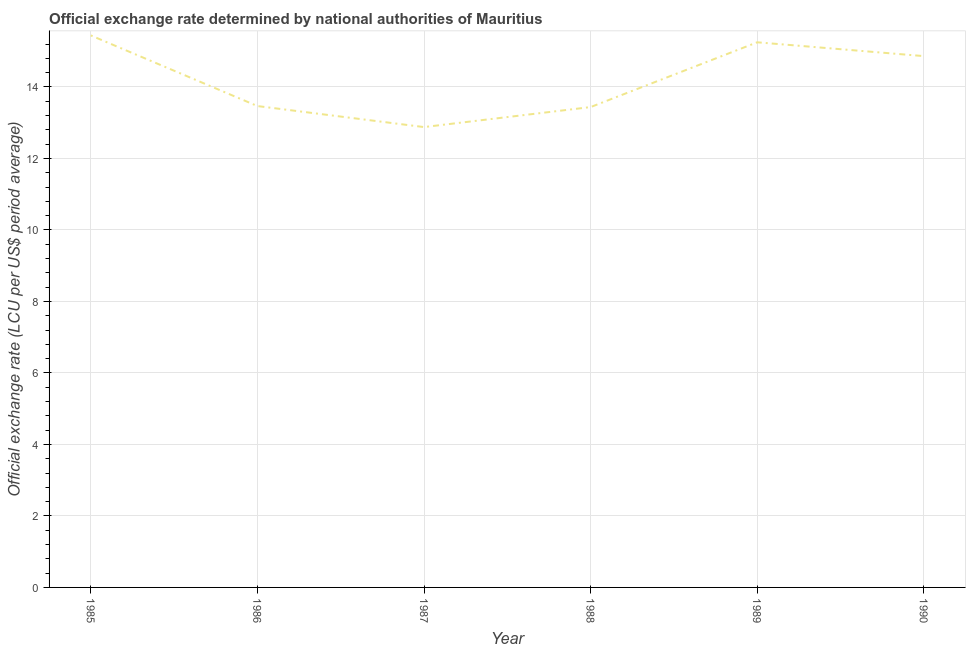What is the official exchange rate in 1985?
Make the answer very short. 15.44. Across all years, what is the maximum official exchange rate?
Provide a short and direct response. 15.44. Across all years, what is the minimum official exchange rate?
Your answer should be very brief. 12.88. What is the sum of the official exchange rate?
Give a very brief answer. 85.34. What is the difference between the official exchange rate in 1985 and 1987?
Your response must be concise. 2.56. What is the average official exchange rate per year?
Your answer should be very brief. 14.22. What is the median official exchange rate?
Keep it short and to the point. 14.16. Do a majority of the years between 1985 and 1988 (inclusive) have official exchange rate greater than 6.4 ?
Give a very brief answer. Yes. What is the ratio of the official exchange rate in 1987 to that in 1988?
Provide a succinct answer. 0.96. Is the difference between the official exchange rate in 1988 and 1989 greater than the difference between any two years?
Your answer should be compact. No. What is the difference between the highest and the second highest official exchange rate?
Make the answer very short. 0.19. What is the difference between the highest and the lowest official exchange rate?
Keep it short and to the point. 2.56. In how many years, is the official exchange rate greater than the average official exchange rate taken over all years?
Your response must be concise. 3. Does the official exchange rate monotonically increase over the years?
Your answer should be very brief. No. How many lines are there?
Make the answer very short. 1. What is the difference between two consecutive major ticks on the Y-axis?
Give a very brief answer. 2. Are the values on the major ticks of Y-axis written in scientific E-notation?
Offer a terse response. No. What is the title of the graph?
Your response must be concise. Official exchange rate determined by national authorities of Mauritius. What is the label or title of the X-axis?
Provide a short and direct response. Year. What is the label or title of the Y-axis?
Offer a terse response. Official exchange rate (LCU per US$ period average). What is the Official exchange rate (LCU per US$ period average) of 1985?
Provide a short and direct response. 15.44. What is the Official exchange rate (LCU per US$ period average) of 1986?
Offer a very short reply. 13.47. What is the Official exchange rate (LCU per US$ period average) of 1987?
Provide a short and direct response. 12.88. What is the Official exchange rate (LCU per US$ period average) in 1988?
Keep it short and to the point. 13.44. What is the Official exchange rate (LCU per US$ period average) in 1989?
Your response must be concise. 15.25. What is the Official exchange rate (LCU per US$ period average) of 1990?
Provide a succinct answer. 14.86. What is the difference between the Official exchange rate (LCU per US$ period average) in 1985 and 1986?
Your answer should be very brief. 1.98. What is the difference between the Official exchange rate (LCU per US$ period average) in 1985 and 1987?
Your answer should be compact. 2.56. What is the difference between the Official exchange rate (LCU per US$ period average) in 1985 and 1988?
Make the answer very short. 2. What is the difference between the Official exchange rate (LCU per US$ period average) in 1985 and 1989?
Your response must be concise. 0.19. What is the difference between the Official exchange rate (LCU per US$ period average) in 1985 and 1990?
Make the answer very short. 0.58. What is the difference between the Official exchange rate (LCU per US$ period average) in 1986 and 1987?
Your response must be concise. 0.59. What is the difference between the Official exchange rate (LCU per US$ period average) in 1986 and 1988?
Provide a succinct answer. 0.03. What is the difference between the Official exchange rate (LCU per US$ period average) in 1986 and 1989?
Provide a short and direct response. -1.78. What is the difference between the Official exchange rate (LCU per US$ period average) in 1986 and 1990?
Ensure brevity in your answer.  -1.4. What is the difference between the Official exchange rate (LCU per US$ period average) in 1987 and 1988?
Ensure brevity in your answer.  -0.56. What is the difference between the Official exchange rate (LCU per US$ period average) in 1987 and 1989?
Offer a very short reply. -2.37. What is the difference between the Official exchange rate (LCU per US$ period average) in 1987 and 1990?
Your answer should be compact. -1.99. What is the difference between the Official exchange rate (LCU per US$ period average) in 1988 and 1989?
Provide a succinct answer. -1.81. What is the difference between the Official exchange rate (LCU per US$ period average) in 1988 and 1990?
Your answer should be very brief. -1.43. What is the difference between the Official exchange rate (LCU per US$ period average) in 1989 and 1990?
Offer a terse response. 0.39. What is the ratio of the Official exchange rate (LCU per US$ period average) in 1985 to that in 1986?
Offer a very short reply. 1.15. What is the ratio of the Official exchange rate (LCU per US$ period average) in 1985 to that in 1987?
Your answer should be compact. 1.2. What is the ratio of the Official exchange rate (LCU per US$ period average) in 1985 to that in 1988?
Your response must be concise. 1.15. What is the ratio of the Official exchange rate (LCU per US$ period average) in 1985 to that in 1990?
Give a very brief answer. 1.04. What is the ratio of the Official exchange rate (LCU per US$ period average) in 1986 to that in 1987?
Offer a terse response. 1.05. What is the ratio of the Official exchange rate (LCU per US$ period average) in 1986 to that in 1989?
Offer a terse response. 0.88. What is the ratio of the Official exchange rate (LCU per US$ period average) in 1986 to that in 1990?
Offer a terse response. 0.91. What is the ratio of the Official exchange rate (LCU per US$ period average) in 1987 to that in 1988?
Your answer should be compact. 0.96. What is the ratio of the Official exchange rate (LCU per US$ period average) in 1987 to that in 1989?
Make the answer very short. 0.84. What is the ratio of the Official exchange rate (LCU per US$ period average) in 1987 to that in 1990?
Offer a very short reply. 0.87. What is the ratio of the Official exchange rate (LCU per US$ period average) in 1988 to that in 1989?
Your answer should be compact. 0.88. What is the ratio of the Official exchange rate (LCU per US$ period average) in 1988 to that in 1990?
Ensure brevity in your answer.  0.9. What is the ratio of the Official exchange rate (LCU per US$ period average) in 1989 to that in 1990?
Keep it short and to the point. 1.03. 